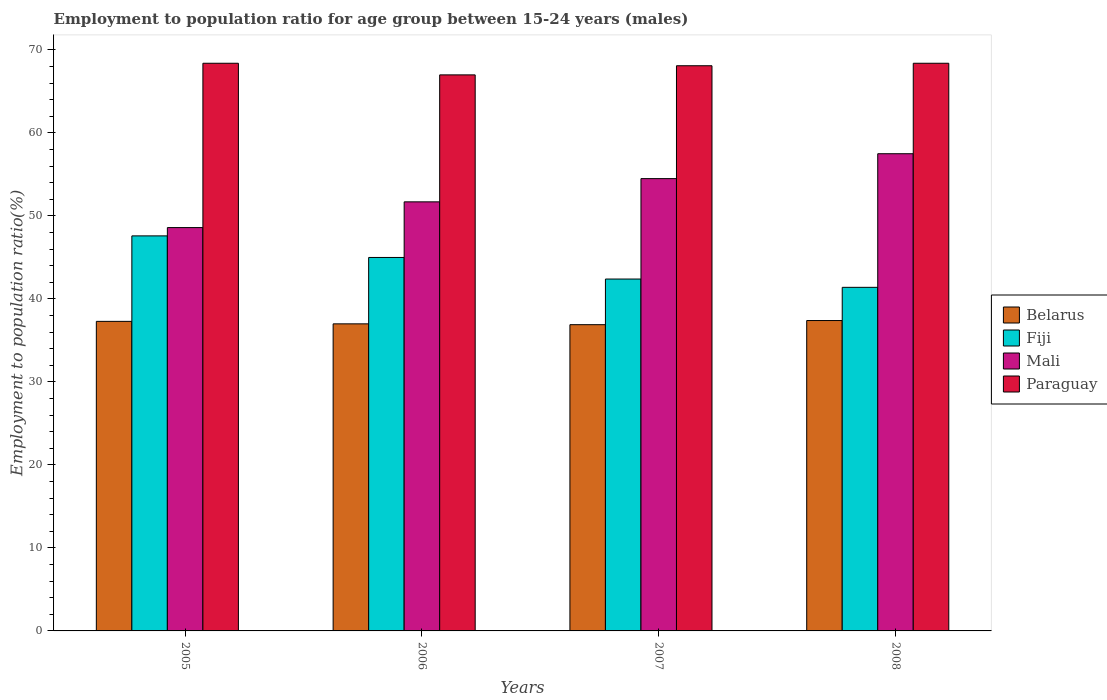How many different coloured bars are there?
Provide a short and direct response. 4. Are the number of bars on each tick of the X-axis equal?
Give a very brief answer. Yes. How many bars are there on the 4th tick from the left?
Make the answer very short. 4. How many bars are there on the 3rd tick from the right?
Ensure brevity in your answer.  4. What is the label of the 2nd group of bars from the left?
Give a very brief answer. 2006. In how many cases, is the number of bars for a given year not equal to the number of legend labels?
Ensure brevity in your answer.  0. What is the employment to population ratio in Paraguay in 2007?
Offer a terse response. 68.1. Across all years, what is the maximum employment to population ratio in Paraguay?
Your answer should be very brief. 68.4. Across all years, what is the minimum employment to population ratio in Paraguay?
Offer a very short reply. 67. In which year was the employment to population ratio in Mali minimum?
Provide a succinct answer. 2005. What is the total employment to population ratio in Fiji in the graph?
Your response must be concise. 176.4. What is the difference between the employment to population ratio in Mali in 2005 and that in 2008?
Provide a short and direct response. -8.9. What is the difference between the employment to population ratio in Paraguay in 2008 and the employment to population ratio in Belarus in 2007?
Offer a terse response. 31.5. What is the average employment to population ratio in Mali per year?
Give a very brief answer. 53.07. In the year 2008, what is the difference between the employment to population ratio in Mali and employment to population ratio in Fiji?
Offer a very short reply. 16.1. In how many years, is the employment to population ratio in Fiji greater than 36 %?
Offer a terse response. 4. What is the ratio of the employment to population ratio in Fiji in 2005 to that in 2007?
Give a very brief answer. 1.12. Is the employment to population ratio in Paraguay in 2007 less than that in 2008?
Make the answer very short. Yes. What is the difference between the highest and the lowest employment to population ratio in Belarus?
Your answer should be compact. 0.5. In how many years, is the employment to population ratio in Fiji greater than the average employment to population ratio in Fiji taken over all years?
Your answer should be very brief. 2. Is the sum of the employment to population ratio in Paraguay in 2007 and 2008 greater than the maximum employment to population ratio in Mali across all years?
Ensure brevity in your answer.  Yes. Is it the case that in every year, the sum of the employment to population ratio in Mali and employment to population ratio in Fiji is greater than the sum of employment to population ratio in Paraguay and employment to population ratio in Belarus?
Offer a very short reply. Yes. What does the 3rd bar from the left in 2006 represents?
Ensure brevity in your answer.  Mali. What does the 1st bar from the right in 2005 represents?
Your answer should be very brief. Paraguay. Are all the bars in the graph horizontal?
Offer a terse response. No. How many legend labels are there?
Provide a short and direct response. 4. What is the title of the graph?
Your answer should be very brief. Employment to population ratio for age group between 15-24 years (males). What is the Employment to population ratio(%) of Belarus in 2005?
Your answer should be very brief. 37.3. What is the Employment to population ratio(%) of Fiji in 2005?
Provide a short and direct response. 47.6. What is the Employment to population ratio(%) of Mali in 2005?
Provide a succinct answer. 48.6. What is the Employment to population ratio(%) in Paraguay in 2005?
Ensure brevity in your answer.  68.4. What is the Employment to population ratio(%) in Belarus in 2006?
Offer a very short reply. 37. What is the Employment to population ratio(%) of Mali in 2006?
Ensure brevity in your answer.  51.7. What is the Employment to population ratio(%) in Paraguay in 2006?
Make the answer very short. 67. What is the Employment to population ratio(%) in Belarus in 2007?
Give a very brief answer. 36.9. What is the Employment to population ratio(%) of Fiji in 2007?
Keep it short and to the point. 42.4. What is the Employment to population ratio(%) in Mali in 2007?
Make the answer very short. 54.5. What is the Employment to population ratio(%) in Paraguay in 2007?
Keep it short and to the point. 68.1. What is the Employment to population ratio(%) in Belarus in 2008?
Give a very brief answer. 37.4. What is the Employment to population ratio(%) in Fiji in 2008?
Provide a succinct answer. 41.4. What is the Employment to population ratio(%) of Mali in 2008?
Make the answer very short. 57.5. What is the Employment to population ratio(%) of Paraguay in 2008?
Offer a very short reply. 68.4. Across all years, what is the maximum Employment to population ratio(%) of Belarus?
Give a very brief answer. 37.4. Across all years, what is the maximum Employment to population ratio(%) of Fiji?
Ensure brevity in your answer.  47.6. Across all years, what is the maximum Employment to population ratio(%) of Mali?
Make the answer very short. 57.5. Across all years, what is the maximum Employment to population ratio(%) of Paraguay?
Your answer should be compact. 68.4. Across all years, what is the minimum Employment to population ratio(%) of Belarus?
Offer a terse response. 36.9. Across all years, what is the minimum Employment to population ratio(%) of Fiji?
Offer a terse response. 41.4. Across all years, what is the minimum Employment to population ratio(%) of Mali?
Your answer should be very brief. 48.6. What is the total Employment to population ratio(%) in Belarus in the graph?
Make the answer very short. 148.6. What is the total Employment to population ratio(%) of Fiji in the graph?
Provide a succinct answer. 176.4. What is the total Employment to population ratio(%) of Mali in the graph?
Make the answer very short. 212.3. What is the total Employment to population ratio(%) in Paraguay in the graph?
Ensure brevity in your answer.  271.9. What is the difference between the Employment to population ratio(%) of Belarus in 2005 and that in 2006?
Give a very brief answer. 0.3. What is the difference between the Employment to population ratio(%) of Fiji in 2005 and that in 2006?
Offer a very short reply. 2.6. What is the difference between the Employment to population ratio(%) of Mali in 2005 and that in 2006?
Ensure brevity in your answer.  -3.1. What is the difference between the Employment to population ratio(%) in Belarus in 2005 and that in 2007?
Ensure brevity in your answer.  0.4. What is the difference between the Employment to population ratio(%) in Fiji in 2005 and that in 2007?
Provide a short and direct response. 5.2. What is the difference between the Employment to population ratio(%) of Paraguay in 2005 and that in 2007?
Keep it short and to the point. 0.3. What is the difference between the Employment to population ratio(%) of Belarus in 2006 and that in 2007?
Provide a short and direct response. 0.1. What is the difference between the Employment to population ratio(%) in Mali in 2006 and that in 2007?
Ensure brevity in your answer.  -2.8. What is the difference between the Employment to population ratio(%) in Paraguay in 2006 and that in 2007?
Provide a succinct answer. -1.1. What is the difference between the Employment to population ratio(%) of Belarus in 2006 and that in 2008?
Make the answer very short. -0.4. What is the difference between the Employment to population ratio(%) of Fiji in 2006 and that in 2008?
Offer a very short reply. 3.6. What is the difference between the Employment to population ratio(%) in Mali in 2006 and that in 2008?
Provide a short and direct response. -5.8. What is the difference between the Employment to population ratio(%) in Belarus in 2007 and that in 2008?
Ensure brevity in your answer.  -0.5. What is the difference between the Employment to population ratio(%) of Paraguay in 2007 and that in 2008?
Offer a terse response. -0.3. What is the difference between the Employment to population ratio(%) of Belarus in 2005 and the Employment to population ratio(%) of Mali in 2006?
Your answer should be very brief. -14.4. What is the difference between the Employment to population ratio(%) of Belarus in 2005 and the Employment to population ratio(%) of Paraguay in 2006?
Offer a terse response. -29.7. What is the difference between the Employment to population ratio(%) in Fiji in 2005 and the Employment to population ratio(%) in Mali in 2006?
Make the answer very short. -4.1. What is the difference between the Employment to population ratio(%) of Fiji in 2005 and the Employment to population ratio(%) of Paraguay in 2006?
Your response must be concise. -19.4. What is the difference between the Employment to population ratio(%) in Mali in 2005 and the Employment to population ratio(%) in Paraguay in 2006?
Offer a terse response. -18.4. What is the difference between the Employment to population ratio(%) of Belarus in 2005 and the Employment to population ratio(%) of Mali in 2007?
Ensure brevity in your answer.  -17.2. What is the difference between the Employment to population ratio(%) of Belarus in 2005 and the Employment to population ratio(%) of Paraguay in 2007?
Make the answer very short. -30.8. What is the difference between the Employment to population ratio(%) in Fiji in 2005 and the Employment to population ratio(%) in Mali in 2007?
Provide a short and direct response. -6.9. What is the difference between the Employment to population ratio(%) of Fiji in 2005 and the Employment to population ratio(%) of Paraguay in 2007?
Keep it short and to the point. -20.5. What is the difference between the Employment to population ratio(%) of Mali in 2005 and the Employment to population ratio(%) of Paraguay in 2007?
Your answer should be compact. -19.5. What is the difference between the Employment to population ratio(%) of Belarus in 2005 and the Employment to population ratio(%) of Fiji in 2008?
Your answer should be compact. -4.1. What is the difference between the Employment to population ratio(%) of Belarus in 2005 and the Employment to population ratio(%) of Mali in 2008?
Your response must be concise. -20.2. What is the difference between the Employment to population ratio(%) in Belarus in 2005 and the Employment to population ratio(%) in Paraguay in 2008?
Ensure brevity in your answer.  -31.1. What is the difference between the Employment to population ratio(%) in Fiji in 2005 and the Employment to population ratio(%) in Paraguay in 2008?
Your answer should be compact. -20.8. What is the difference between the Employment to population ratio(%) of Mali in 2005 and the Employment to population ratio(%) of Paraguay in 2008?
Provide a short and direct response. -19.8. What is the difference between the Employment to population ratio(%) of Belarus in 2006 and the Employment to population ratio(%) of Fiji in 2007?
Keep it short and to the point. -5.4. What is the difference between the Employment to population ratio(%) of Belarus in 2006 and the Employment to population ratio(%) of Mali in 2007?
Your answer should be very brief. -17.5. What is the difference between the Employment to population ratio(%) in Belarus in 2006 and the Employment to population ratio(%) in Paraguay in 2007?
Your response must be concise. -31.1. What is the difference between the Employment to population ratio(%) in Fiji in 2006 and the Employment to population ratio(%) in Mali in 2007?
Give a very brief answer. -9.5. What is the difference between the Employment to population ratio(%) in Fiji in 2006 and the Employment to population ratio(%) in Paraguay in 2007?
Keep it short and to the point. -23.1. What is the difference between the Employment to population ratio(%) of Mali in 2006 and the Employment to population ratio(%) of Paraguay in 2007?
Your answer should be compact. -16.4. What is the difference between the Employment to population ratio(%) of Belarus in 2006 and the Employment to population ratio(%) of Mali in 2008?
Your response must be concise. -20.5. What is the difference between the Employment to population ratio(%) in Belarus in 2006 and the Employment to population ratio(%) in Paraguay in 2008?
Offer a very short reply. -31.4. What is the difference between the Employment to population ratio(%) in Fiji in 2006 and the Employment to population ratio(%) in Paraguay in 2008?
Your response must be concise. -23.4. What is the difference between the Employment to population ratio(%) of Mali in 2006 and the Employment to population ratio(%) of Paraguay in 2008?
Offer a terse response. -16.7. What is the difference between the Employment to population ratio(%) of Belarus in 2007 and the Employment to population ratio(%) of Mali in 2008?
Offer a very short reply. -20.6. What is the difference between the Employment to population ratio(%) of Belarus in 2007 and the Employment to population ratio(%) of Paraguay in 2008?
Your response must be concise. -31.5. What is the difference between the Employment to population ratio(%) of Fiji in 2007 and the Employment to population ratio(%) of Mali in 2008?
Give a very brief answer. -15.1. What is the difference between the Employment to population ratio(%) in Fiji in 2007 and the Employment to population ratio(%) in Paraguay in 2008?
Offer a very short reply. -26. What is the difference between the Employment to population ratio(%) in Mali in 2007 and the Employment to population ratio(%) in Paraguay in 2008?
Provide a short and direct response. -13.9. What is the average Employment to population ratio(%) in Belarus per year?
Keep it short and to the point. 37.15. What is the average Employment to population ratio(%) of Fiji per year?
Your answer should be very brief. 44.1. What is the average Employment to population ratio(%) in Mali per year?
Keep it short and to the point. 53.08. What is the average Employment to population ratio(%) in Paraguay per year?
Give a very brief answer. 67.97. In the year 2005, what is the difference between the Employment to population ratio(%) in Belarus and Employment to population ratio(%) in Paraguay?
Your response must be concise. -31.1. In the year 2005, what is the difference between the Employment to population ratio(%) of Fiji and Employment to population ratio(%) of Paraguay?
Your answer should be very brief. -20.8. In the year 2005, what is the difference between the Employment to population ratio(%) of Mali and Employment to population ratio(%) of Paraguay?
Provide a succinct answer. -19.8. In the year 2006, what is the difference between the Employment to population ratio(%) in Belarus and Employment to population ratio(%) in Mali?
Ensure brevity in your answer.  -14.7. In the year 2006, what is the difference between the Employment to population ratio(%) of Fiji and Employment to population ratio(%) of Paraguay?
Provide a short and direct response. -22. In the year 2006, what is the difference between the Employment to population ratio(%) in Mali and Employment to population ratio(%) in Paraguay?
Keep it short and to the point. -15.3. In the year 2007, what is the difference between the Employment to population ratio(%) in Belarus and Employment to population ratio(%) in Fiji?
Provide a short and direct response. -5.5. In the year 2007, what is the difference between the Employment to population ratio(%) in Belarus and Employment to population ratio(%) in Mali?
Your answer should be compact. -17.6. In the year 2007, what is the difference between the Employment to population ratio(%) in Belarus and Employment to population ratio(%) in Paraguay?
Make the answer very short. -31.2. In the year 2007, what is the difference between the Employment to population ratio(%) in Fiji and Employment to population ratio(%) in Paraguay?
Make the answer very short. -25.7. In the year 2007, what is the difference between the Employment to population ratio(%) of Mali and Employment to population ratio(%) of Paraguay?
Offer a very short reply. -13.6. In the year 2008, what is the difference between the Employment to population ratio(%) of Belarus and Employment to population ratio(%) of Mali?
Your answer should be very brief. -20.1. In the year 2008, what is the difference between the Employment to population ratio(%) of Belarus and Employment to population ratio(%) of Paraguay?
Make the answer very short. -31. In the year 2008, what is the difference between the Employment to population ratio(%) of Fiji and Employment to population ratio(%) of Mali?
Offer a terse response. -16.1. In the year 2008, what is the difference between the Employment to population ratio(%) of Mali and Employment to population ratio(%) of Paraguay?
Your response must be concise. -10.9. What is the ratio of the Employment to population ratio(%) of Fiji in 2005 to that in 2006?
Give a very brief answer. 1.06. What is the ratio of the Employment to population ratio(%) of Paraguay in 2005 to that in 2006?
Ensure brevity in your answer.  1.02. What is the ratio of the Employment to population ratio(%) in Belarus in 2005 to that in 2007?
Keep it short and to the point. 1.01. What is the ratio of the Employment to population ratio(%) of Fiji in 2005 to that in 2007?
Offer a very short reply. 1.12. What is the ratio of the Employment to population ratio(%) in Mali in 2005 to that in 2007?
Give a very brief answer. 0.89. What is the ratio of the Employment to population ratio(%) in Fiji in 2005 to that in 2008?
Make the answer very short. 1.15. What is the ratio of the Employment to population ratio(%) of Mali in 2005 to that in 2008?
Offer a very short reply. 0.85. What is the ratio of the Employment to population ratio(%) of Paraguay in 2005 to that in 2008?
Your answer should be very brief. 1. What is the ratio of the Employment to population ratio(%) in Fiji in 2006 to that in 2007?
Keep it short and to the point. 1.06. What is the ratio of the Employment to population ratio(%) of Mali in 2006 to that in 2007?
Your response must be concise. 0.95. What is the ratio of the Employment to population ratio(%) of Paraguay in 2006 to that in 2007?
Offer a terse response. 0.98. What is the ratio of the Employment to population ratio(%) in Belarus in 2006 to that in 2008?
Your answer should be compact. 0.99. What is the ratio of the Employment to population ratio(%) in Fiji in 2006 to that in 2008?
Provide a short and direct response. 1.09. What is the ratio of the Employment to population ratio(%) in Mali in 2006 to that in 2008?
Your answer should be very brief. 0.9. What is the ratio of the Employment to population ratio(%) of Paraguay in 2006 to that in 2008?
Your response must be concise. 0.98. What is the ratio of the Employment to population ratio(%) in Belarus in 2007 to that in 2008?
Give a very brief answer. 0.99. What is the ratio of the Employment to population ratio(%) in Fiji in 2007 to that in 2008?
Your answer should be compact. 1.02. What is the ratio of the Employment to population ratio(%) in Mali in 2007 to that in 2008?
Provide a short and direct response. 0.95. What is the ratio of the Employment to population ratio(%) of Paraguay in 2007 to that in 2008?
Provide a succinct answer. 1. What is the difference between the highest and the second highest Employment to population ratio(%) in Belarus?
Your response must be concise. 0.1. What is the difference between the highest and the second highest Employment to population ratio(%) in Fiji?
Ensure brevity in your answer.  2.6. What is the difference between the highest and the second highest Employment to population ratio(%) in Mali?
Provide a succinct answer. 3. What is the difference between the highest and the second highest Employment to population ratio(%) of Paraguay?
Offer a terse response. 0. What is the difference between the highest and the lowest Employment to population ratio(%) of Mali?
Make the answer very short. 8.9. 